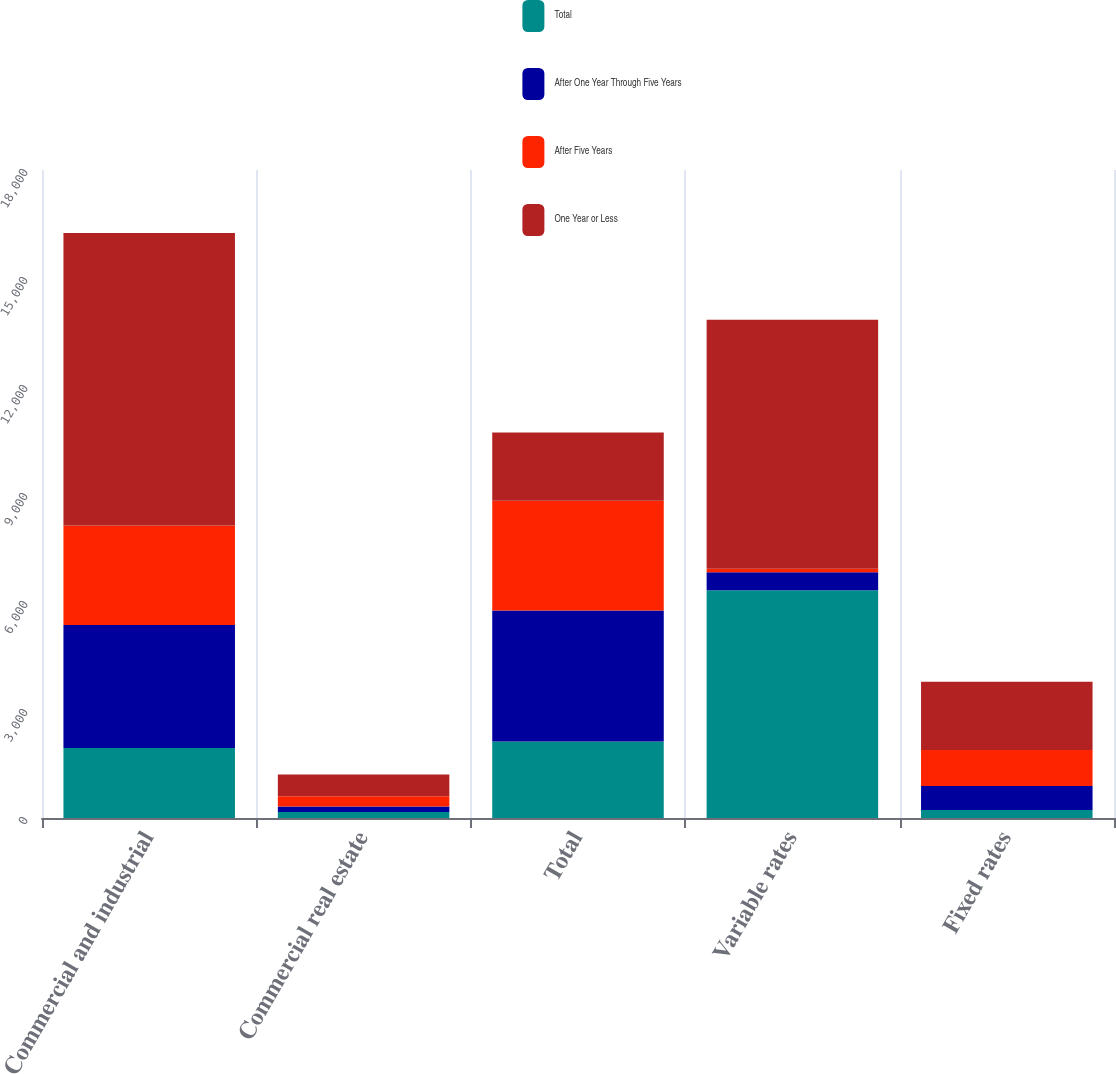Convert chart. <chart><loc_0><loc_0><loc_500><loc_500><stacked_bar_chart><ecel><fcel>Commercial and industrial<fcel>Commercial real estate<fcel>Total<fcel>Variable rates<fcel>Fixed rates<nl><fcel>Total<fcel>1943.6<fcel>166.7<fcel>2123.4<fcel>6326.9<fcel>220.6<nl><fcel>After One Year Through Five Years<fcel>3418.2<fcel>153.2<fcel>3642.5<fcel>500.1<fcel>667.1<nl><fcel>After Five Years<fcel>2763.3<fcel>284.2<fcel>3047.5<fcel>94.5<fcel>1004.2<nl><fcel>One Year or Less<fcel>8125.1<fcel>604.1<fcel>1891.9<fcel>6921.5<fcel>1891.9<nl></chart> 